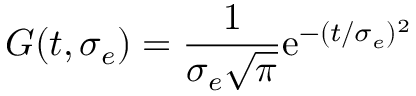<formula> <loc_0><loc_0><loc_500><loc_500>G ( t , \sigma _ { e } ) = \frac { 1 } { \sigma _ { e } \sqrt { \pi } } e ^ { - ( t / \sigma _ { e } ) ^ { 2 } }</formula> 